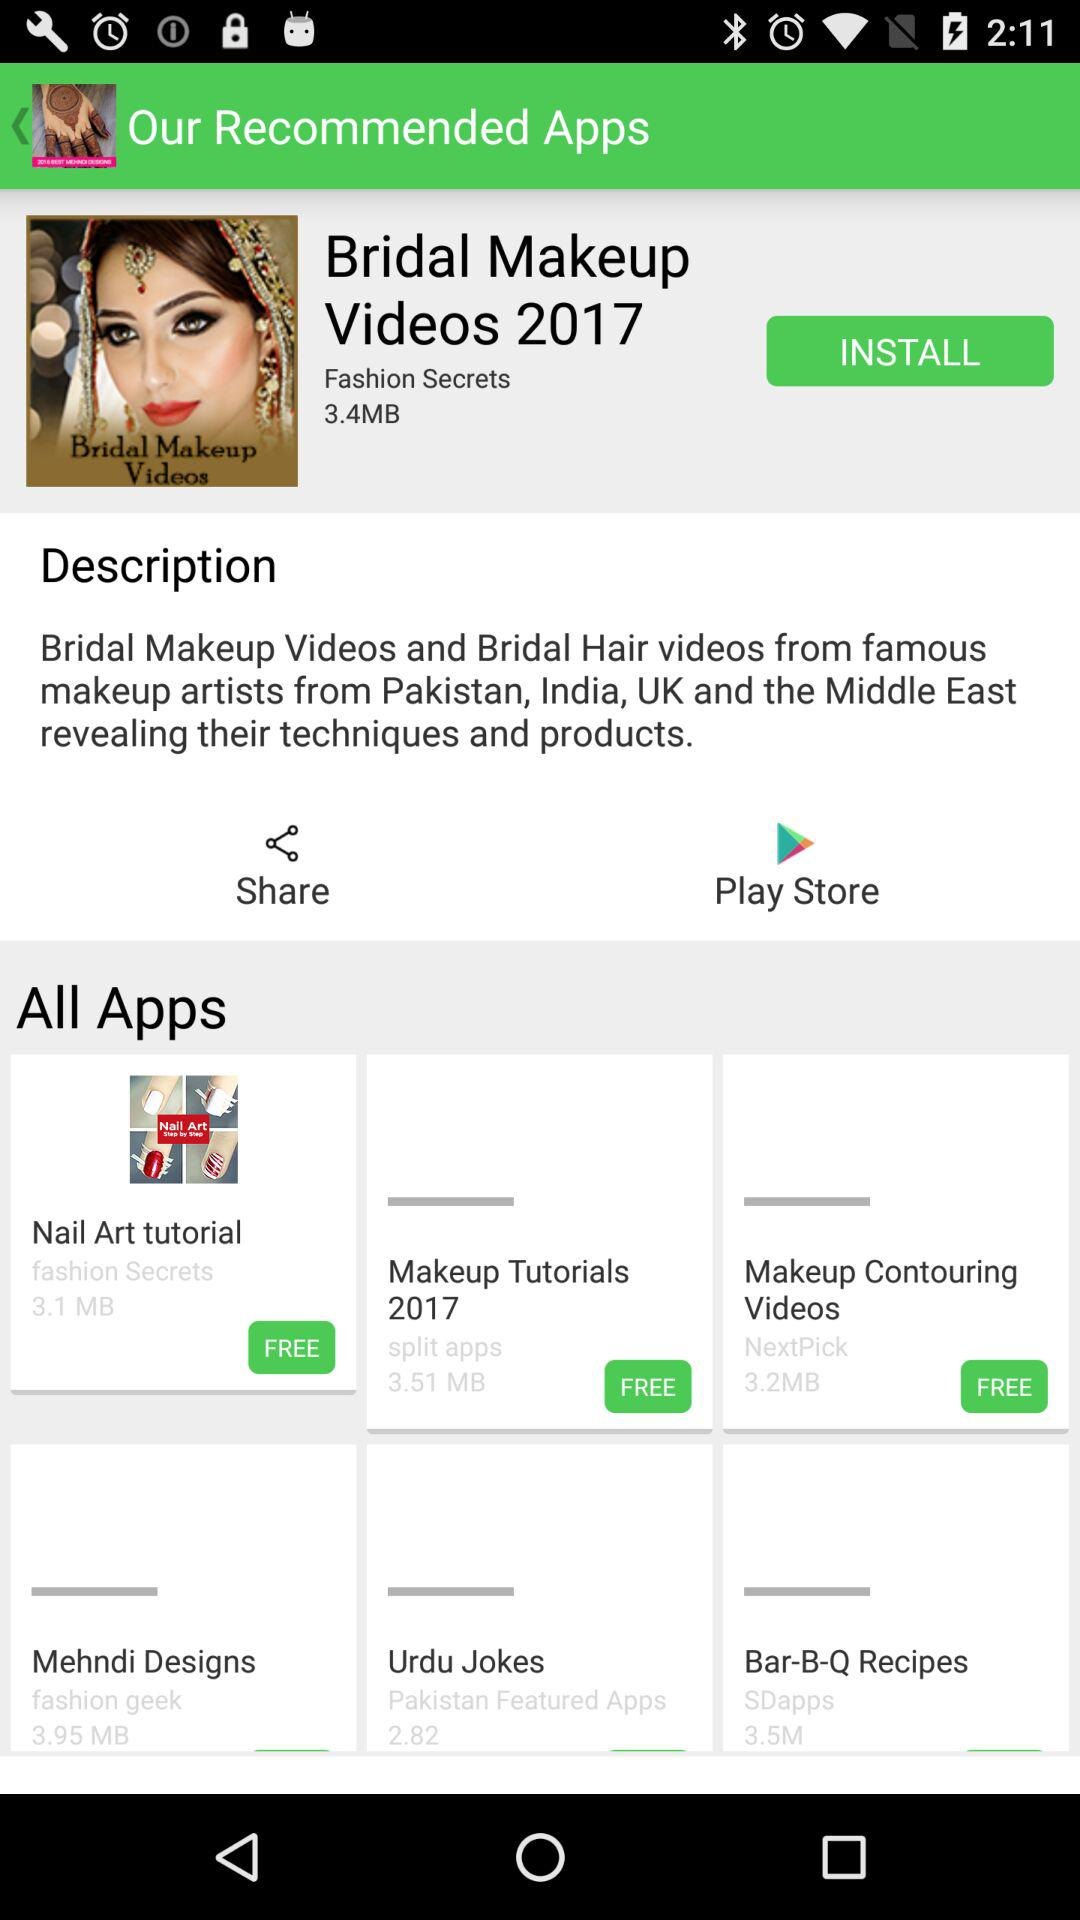How many MB is the size of the largest app?
Answer the question using a single word or phrase. 3.95 